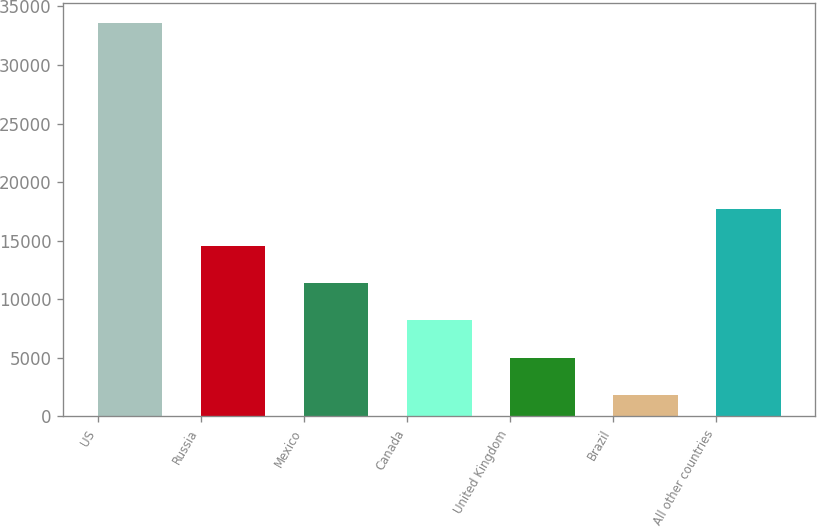<chart> <loc_0><loc_0><loc_500><loc_500><bar_chart><fcel>US<fcel>Russia<fcel>Mexico<fcel>Canada<fcel>United Kingdom<fcel>Brazil<fcel>All other countries<nl><fcel>33626<fcel>14551.4<fcel>11372.3<fcel>8193.2<fcel>5014.1<fcel>1835<fcel>17730.5<nl></chart> 